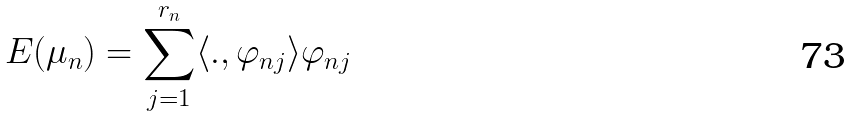<formula> <loc_0><loc_0><loc_500><loc_500>E ( \mu _ { n } ) = \overset { r _ { n } } { \underset { j = 1 } { \sum } } \langle . , \varphi _ { n j } \rangle \varphi _ { n j }</formula> 